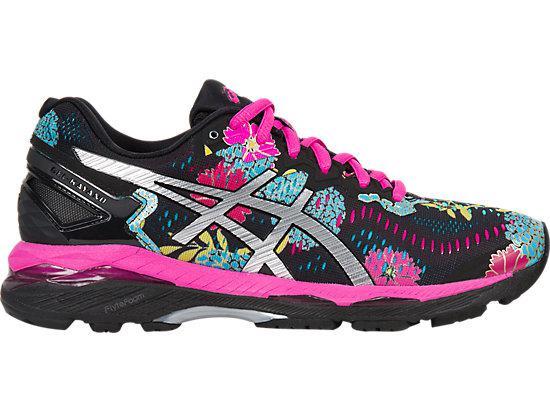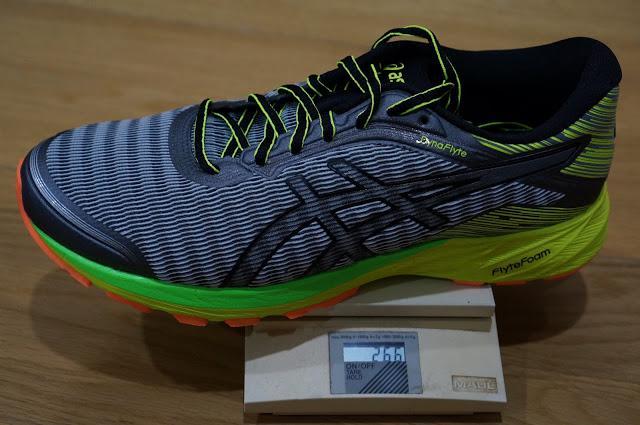The first image is the image on the left, the second image is the image on the right. Considering the images on both sides, is "A shoe is sitting on top of another object." valid? Answer yes or no. Yes. The first image is the image on the left, the second image is the image on the right. Assess this claim about the two images: "There are exactly two sneakers.". Correct or not? Answer yes or no. Yes. 